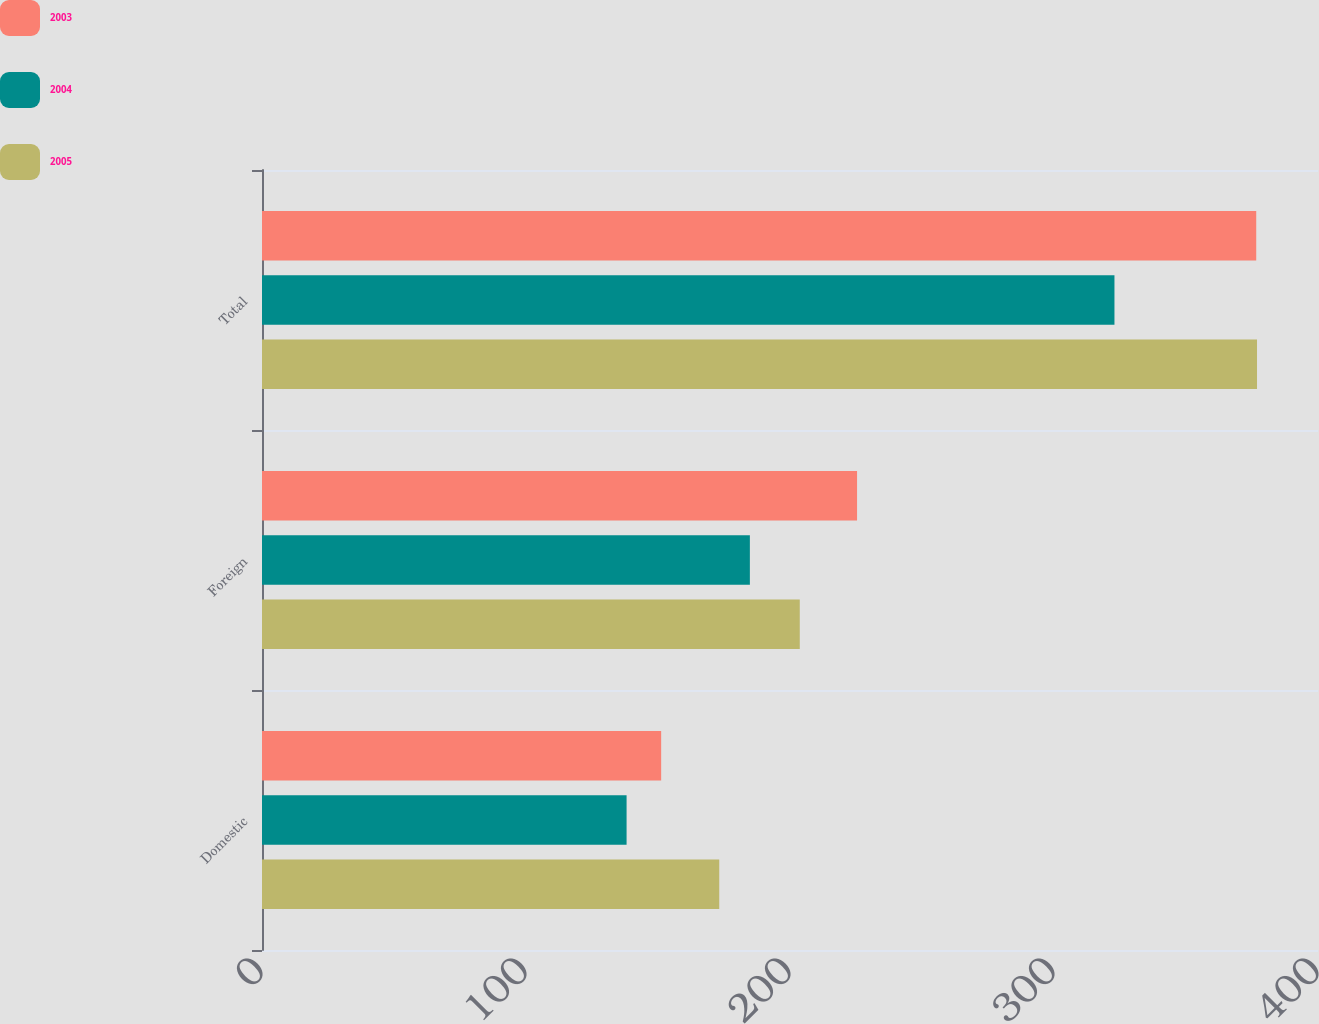Convert chart. <chart><loc_0><loc_0><loc_500><loc_500><stacked_bar_chart><ecel><fcel>Domestic<fcel>Foreign<fcel>Total<nl><fcel>2003<fcel>151.2<fcel>225.4<fcel>376.6<nl><fcel>2004<fcel>138.1<fcel>184.8<fcel>322.9<nl><fcel>2005<fcel>173.2<fcel>203.7<fcel>376.9<nl></chart> 